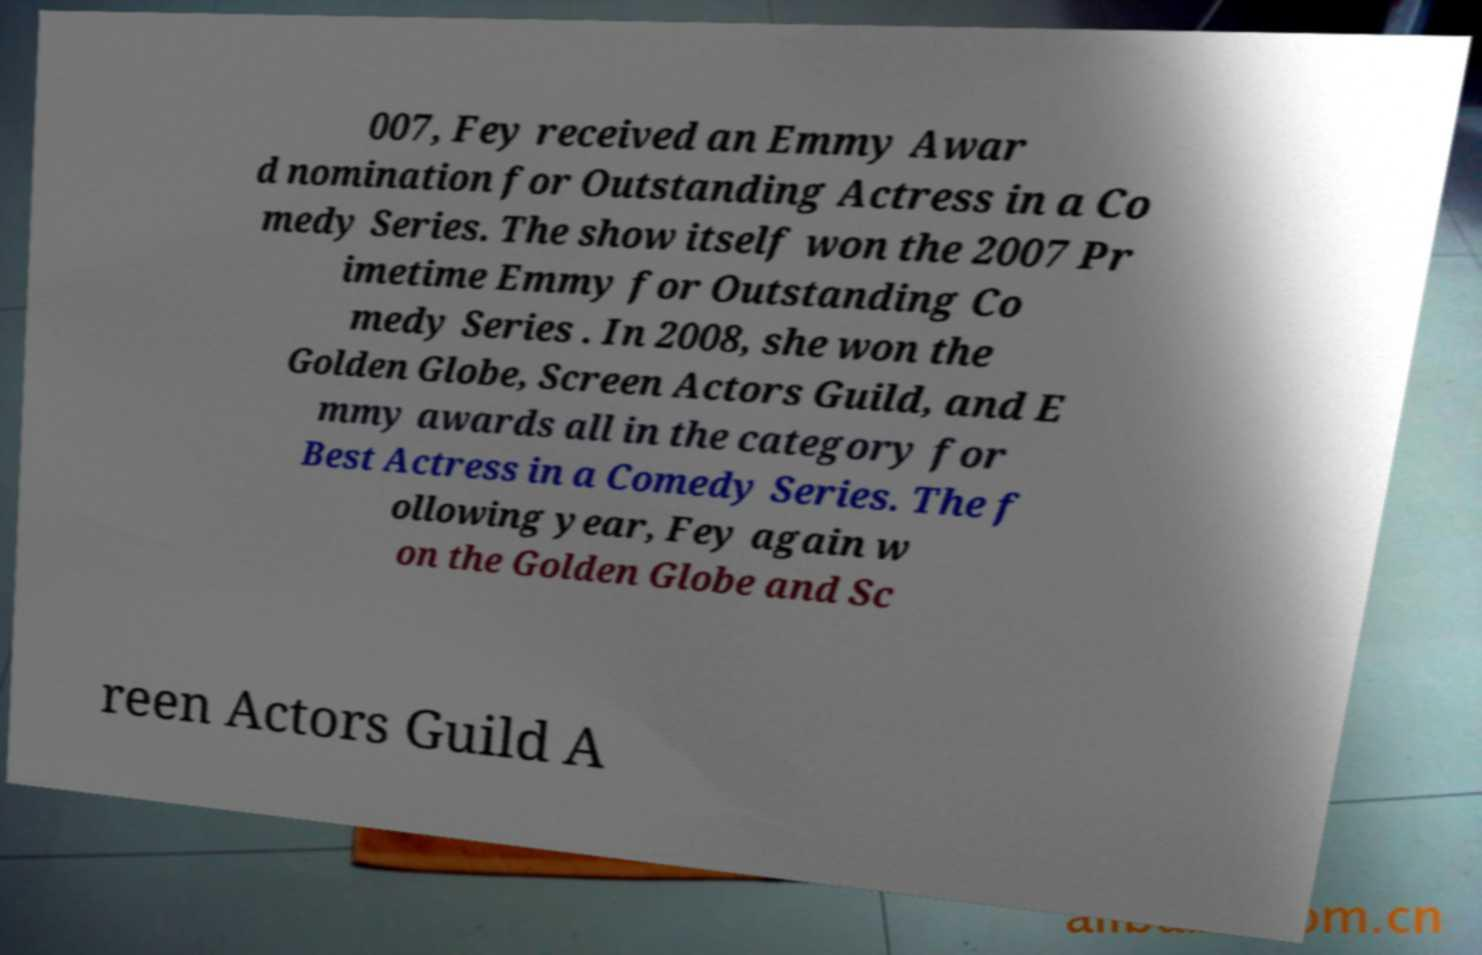Please identify and transcribe the text found in this image. 007, Fey received an Emmy Awar d nomination for Outstanding Actress in a Co medy Series. The show itself won the 2007 Pr imetime Emmy for Outstanding Co medy Series . In 2008, she won the Golden Globe, Screen Actors Guild, and E mmy awards all in the category for Best Actress in a Comedy Series. The f ollowing year, Fey again w on the Golden Globe and Sc reen Actors Guild A 